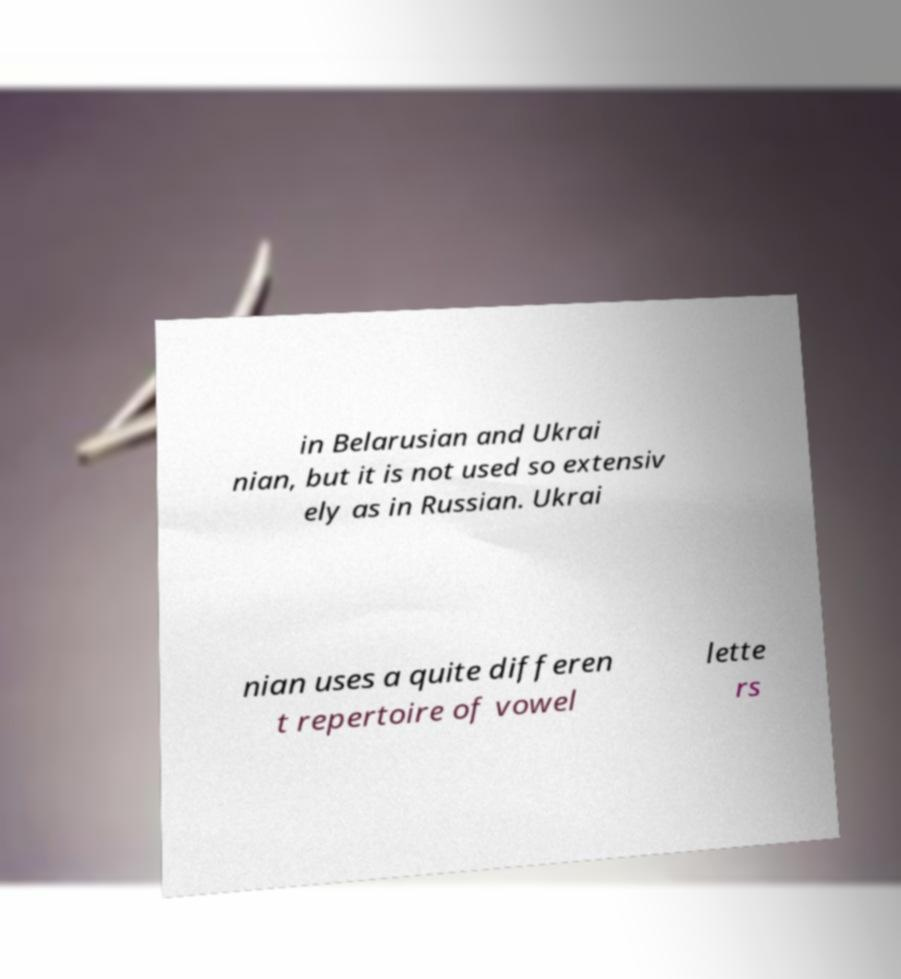What messages or text are displayed in this image? I need them in a readable, typed format. in Belarusian and Ukrai nian, but it is not used so extensiv ely as in Russian. Ukrai nian uses a quite differen t repertoire of vowel lette rs 